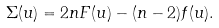<formula> <loc_0><loc_0><loc_500><loc_500>\Sigma ( u ) = 2 n F ( u ) - ( n - 2 ) f ( u ) .</formula> 